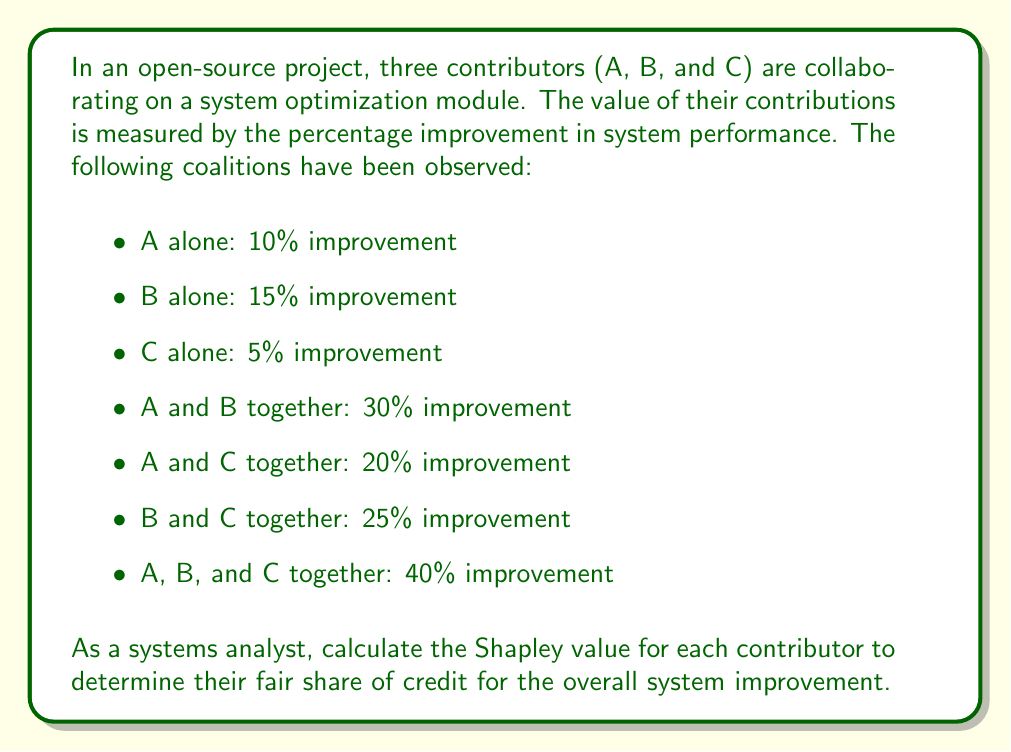Show me your answer to this math problem. To calculate the Shapley value, we need to consider all possible orderings of the contributors and determine their marginal contributions. There are 3! = 6 possible orderings.

Let's define the characteristic function $v(S)$ for each coalition $S$:

$v(\{\}) = 0$
$v(\{A\}) = 10$
$v(\{B\}) = 15$
$v(\{C\}) = 5$
$v(\{A,B\}) = 30$
$v(\{A,C\}) = 20$
$v(\{B,C\}) = 25$
$v(\{A,B,C\}) = 40$

Now, let's calculate the marginal contributions for each ordering:

1. ABC: A(10), B(20), C(10)
2. ACB: A(10), C(10), B(20)
3. BAC: B(15), A(15), C(10)
4. BCA: B(15), C(10), A(15)
5. CAB: C(5), A(15), B(20)
6. CBA: C(5), B(20), A(15)

The Shapley value for each contributor is the average of their marginal contributions:

For A: $\phi_A = \frac{1}{6}(10 + 10 + 15 + 15 + 15 + 15) = \frac{80}{6} = \frac{40}{3}$

For B: $\phi_B = \frac{1}{6}(20 + 20 + 15 + 15 + 20 + 20) = \frac{110}{6} = \frac{55}{3}$

For C: $\phi_C = \frac{1}{6}(10 + 10 + 10 + 10 + 5 + 5) = \frac{50}{6} = \frac{25}{3}$

We can verify that the sum of Shapley values equals the total value of the grand coalition:

$$\phi_A + \phi_B + \phi_C = \frac{40}{3} + \frac{55}{3} + \frac{25}{3} = \frac{120}{3} = 40$$

This matches the value of $v(\{A,B,C\}) = 40$.
Answer: The Shapley values for the contributors are:

A: $\frac{40}{3} \approx 13.33$
B: $\frac{55}{3} \approx 18.33$
C: $\frac{25}{3} \approx 8.33$

These values represent the fair distribution of credit for each contributor's impact on the overall system improvement. 